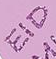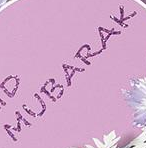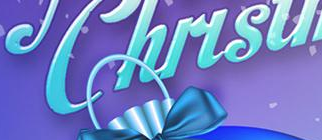What words can you see in these images in sequence, separated by a semicolon? EID; MUBARAK; Chirsu 